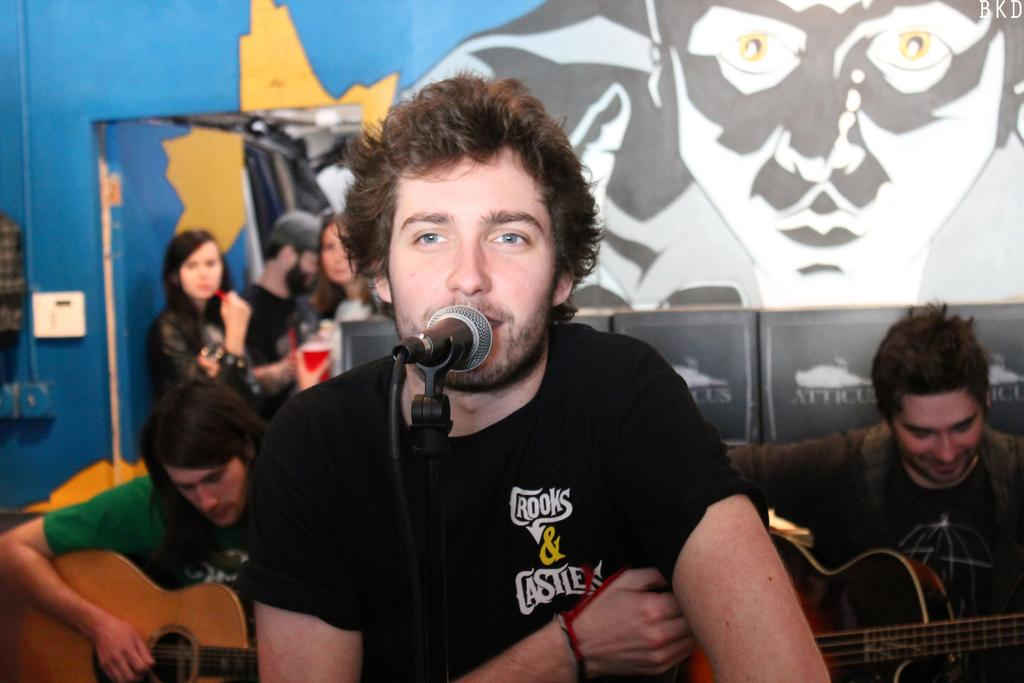How many men are in the image? There are three men in the image. What are two of the men holding? Two of the men are holding guitars. Which man is in front of the picture? One of the men is in front of the picture. What can be seen in the background of the image? There is a wall in the background of the image. How many people are in the background of the image? There are three persons in the background of the image. What type of punishment is being administered to the men in the image? There is no indication of punishment in the image; the men are holding guitars, suggesting they might be musicians or performers. Can you tell me how many people are swimming in the image? There is no swimming activity depicted in the image; it features three men holding guitars and a background with a wall and additional people. 